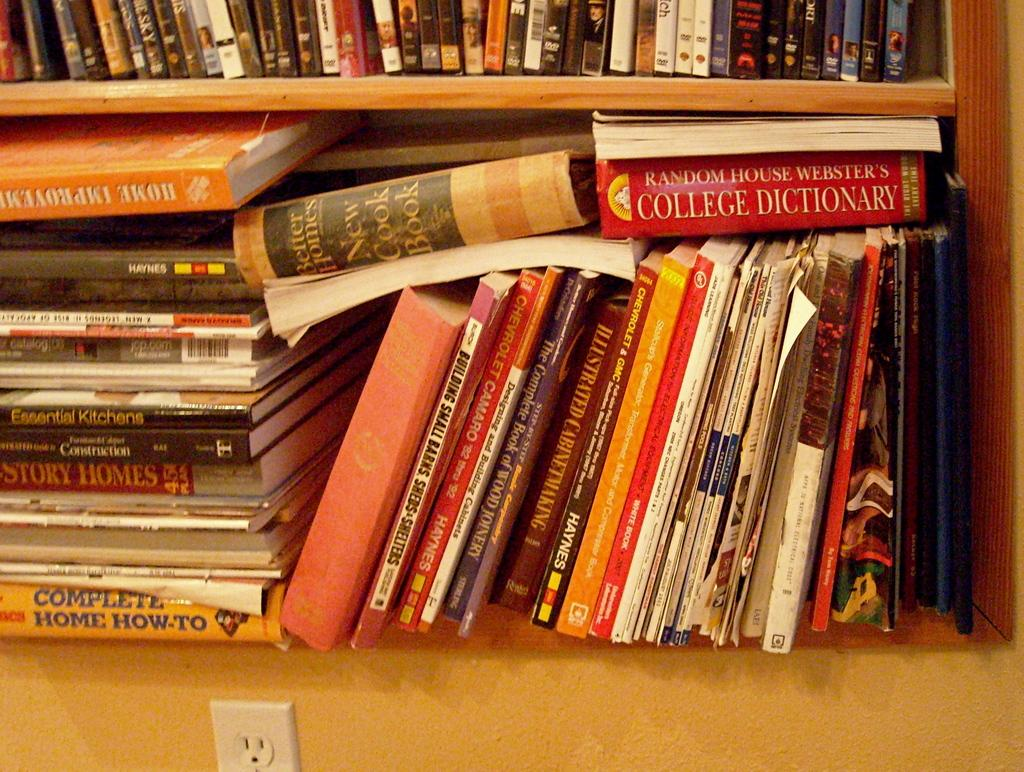<image>
Describe the image concisely. Books stacked on top of one another with the "Complete Home:How-To" on the bottom. 